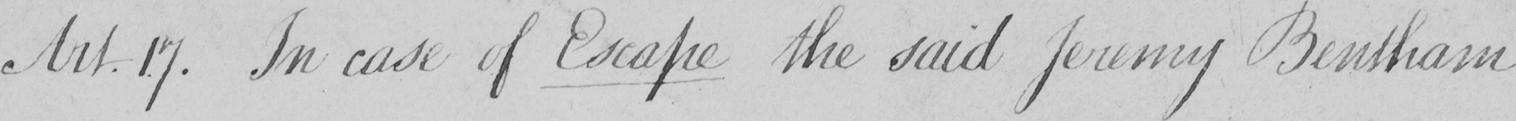Please transcribe the handwritten text in this image. Art.17 . In case of Escape the said Jeremy Bentham 